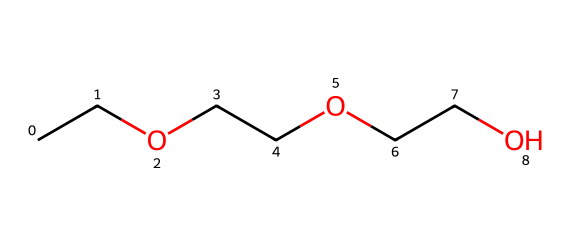What is the name of this chemical? The SMILES representation translates to diethylene glycol monoethyl ether, indicating the presence of ethylene glycol units and an ethyl group in its structure.
Answer: diethylene glycol monoethyl ether How many carbon atoms are in this molecule? The SMILES representation shows three ethylene glycol entities, each contributing two carbon atoms, plus one additional carbon from the ethyl group, totaling.
Answer: six What is the total number of oxygen atoms in the structure? Each ethylene glycol unit has one oxygen, and the structure shows three ethylene glycol units. Therefore, there are three oxygen atoms in total.
Answer: three What type of chemical is this compound categorized as? Given its structural features, specifically the ether linkages (–O–), this compound is classified as an ether.
Answer: ether Does this compound have a hydrophobic or hydrophilic nature? The presence of hydroxyl groups and ether oxygen suggest a hydrophilic nature, making it soluble in water and suitable for cleaning applications.
Answer: hydrophilic What functional groups are present in this molecule? The molecule features ether (–O–) linkages and hydroxyl (–OH) groups, indicative of both ether and alcohol functional groups.
Answer: ether and hydroxyl How can this compound be used in correctional facilities? Its solvent properties make diethylene glycol monoethyl ether effective for cleaning products used to maintain hygiene in correctional institutions.
Answer: cleaning agent 